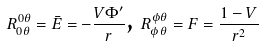<formula> <loc_0><loc_0><loc_500><loc_500>R _ { 0 \theta } ^ { 0 \theta } = \bar { E } = - \frac { V \Phi ^ { \prime } } { r } \text {, } R _ { \phi \theta } ^ { \phi \theta } = F = \frac { 1 - V } { r ^ { 2 } }</formula> 